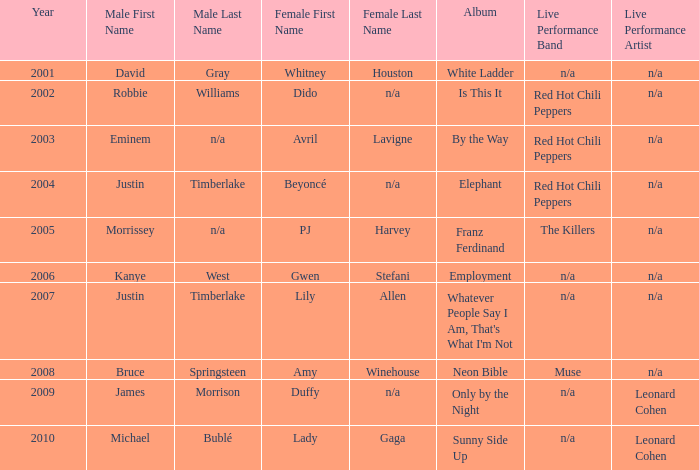Who is the male companion for amy winehouse? Bruce Springsteen. 